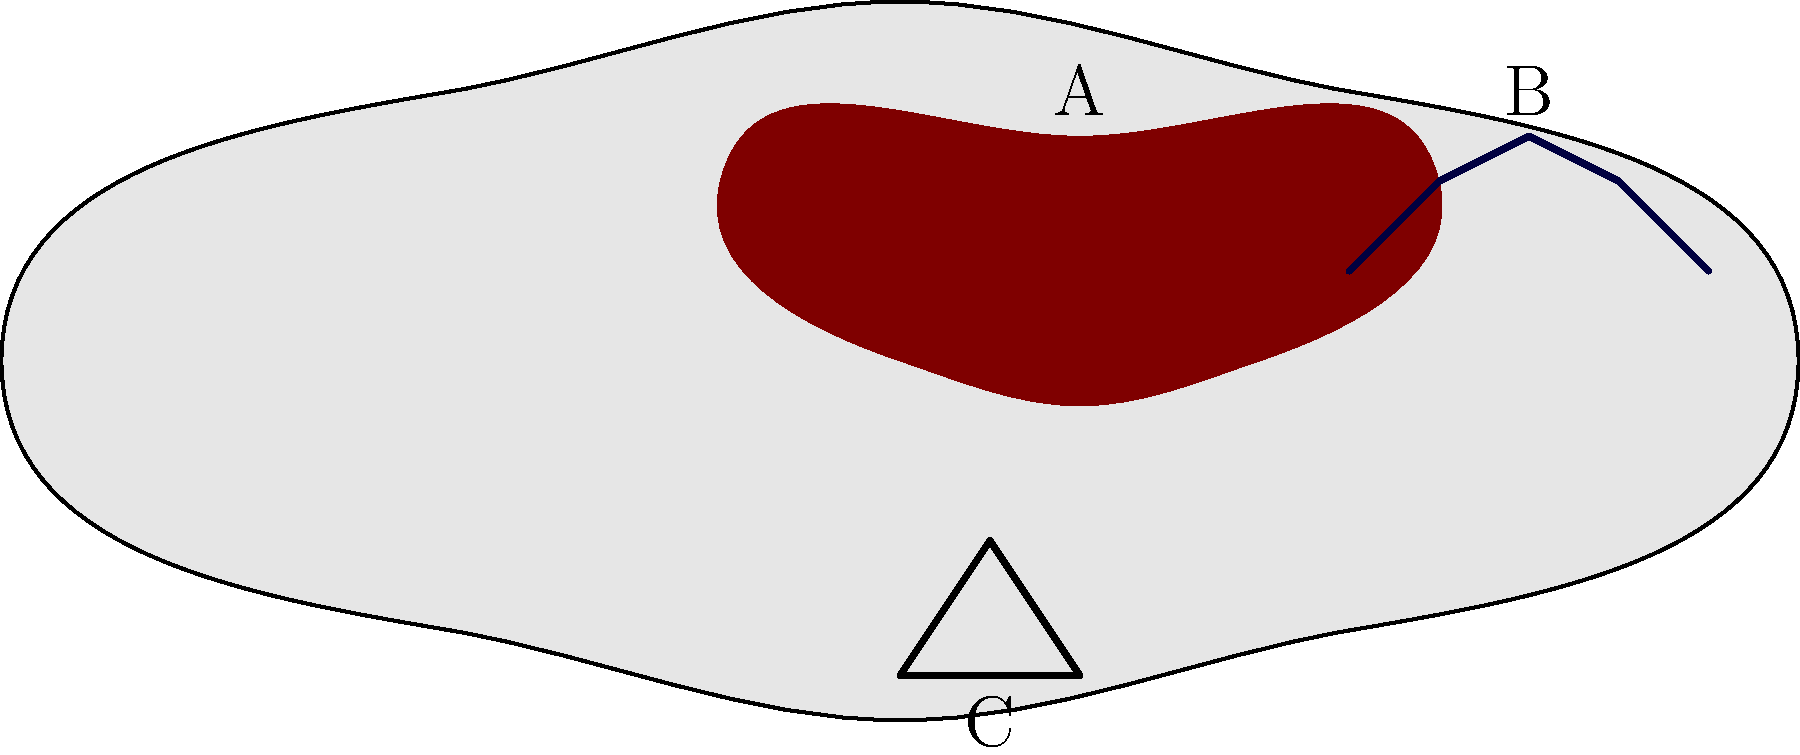Identify the horse tack and equipment labeled A, B, and C in the illustration above. To identify the horse tack and equipment in the illustration, let's examine each labeled item:

1. Item A: This is located on the horse's back and has a curved shape that fits the contour of the horse's body. It's used for the rider to sit on and provides a stable platform for riding. This item is the saddle.

2. Item B: This is positioned on the horse's head and consists of straps that go around the horse's face and behind the ears. It's used to control the horse's head and is a crucial piece of equipment for communication between the rider and the horse. This item is the bridle.

3. Item C: This is a loop-shaped object hanging from the saddle area. It's used by the rider to place their foot in for support and balance while riding. This item is the stirrup.

Understanding these basic pieces of horse tack and equipment is essential for a stable hand working with horses daily.
Answer: A: Saddle, B: Bridle, C: Stirrup 